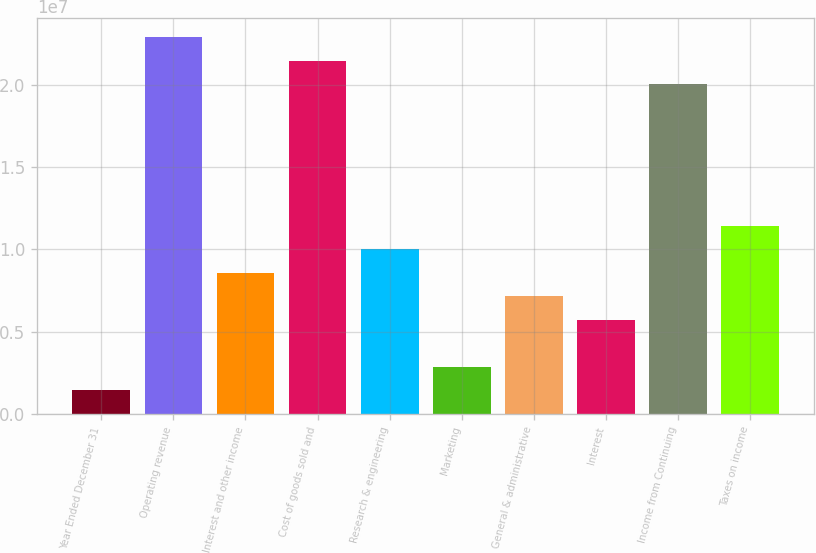Convert chart. <chart><loc_0><loc_0><loc_500><loc_500><bar_chart><fcel>Year Ended December 31<fcel>Operating revenue<fcel>Interest and other income<fcel>Cost of goods sold and<fcel>Research & engineering<fcel>Marketing<fcel>General & administrative<fcel>Interest<fcel>Income from Continuing<fcel>Taxes on income<nl><fcel>1.43092e+06<fcel>2.28947e+07<fcel>8.58551e+06<fcel>2.14638e+07<fcel>1.00164e+07<fcel>2.86184e+06<fcel>7.15459e+06<fcel>5.72367e+06<fcel>2.00329e+07<fcel>1.14473e+07<nl></chart> 